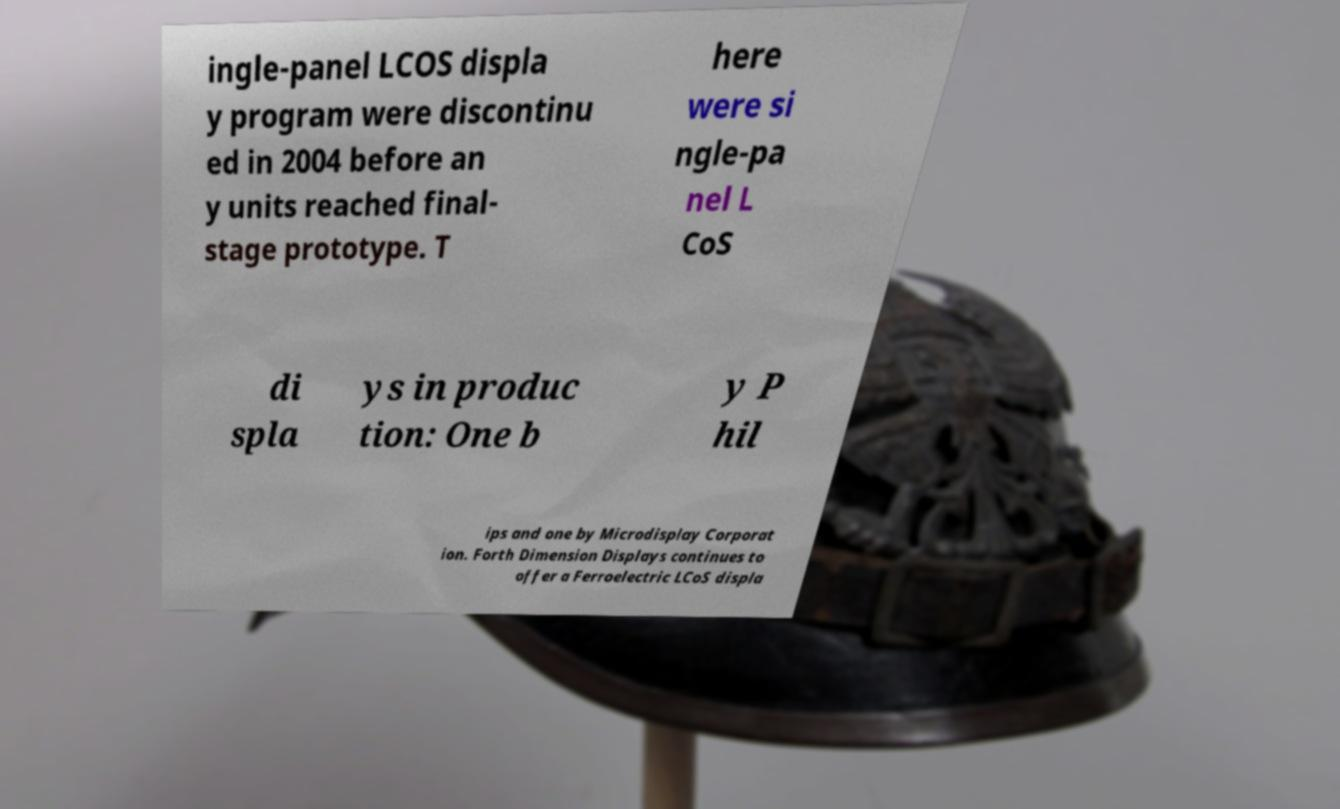Please read and relay the text visible in this image. What does it say? ingle-panel LCOS displa y program were discontinu ed in 2004 before an y units reached final- stage prototype. T here were si ngle-pa nel L CoS di spla ys in produc tion: One b y P hil ips and one by Microdisplay Corporat ion. Forth Dimension Displays continues to offer a Ferroelectric LCoS displa 